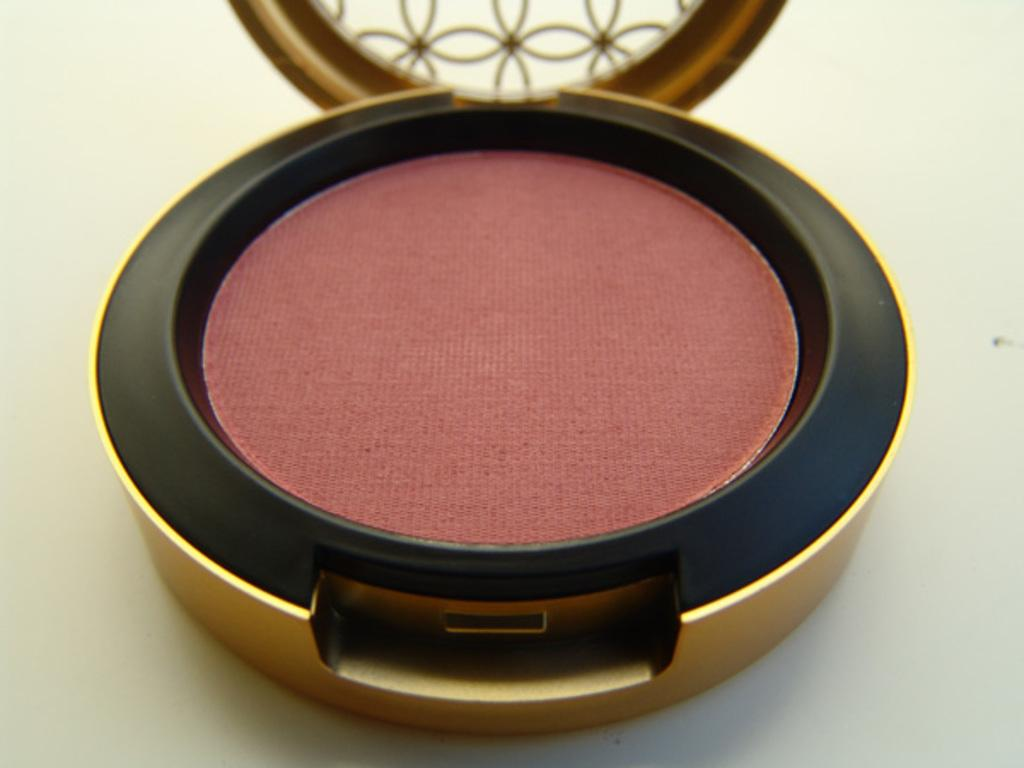What type of cosmetic product is visible in the image? There is a powder blush in the image. Where is the powder blush located? The powder blush is on an object. Is the powder blush being used to crush something in the image? No, the powder blush is not being used to crush anything in the image. 